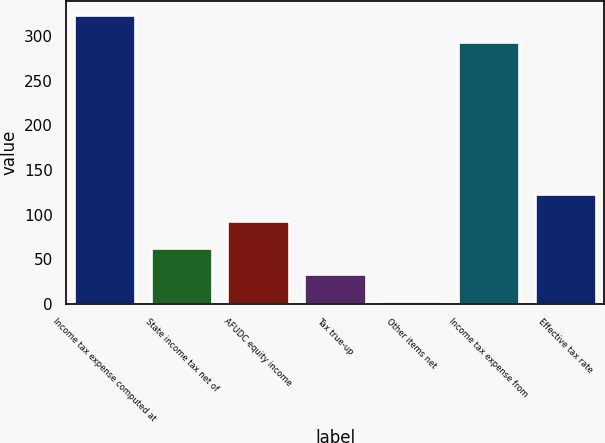Convert chart. <chart><loc_0><loc_0><loc_500><loc_500><bar_chart><fcel>Income tax expense computed at<fcel>State income tax net of<fcel>AFUDC equity income<fcel>Tax true-up<fcel>Other items net<fcel>Income tax expense from<fcel>Effective tax rate<nl><fcel>323.9<fcel>62.8<fcel>92.7<fcel>32.9<fcel>3<fcel>294<fcel>122.6<nl></chart> 